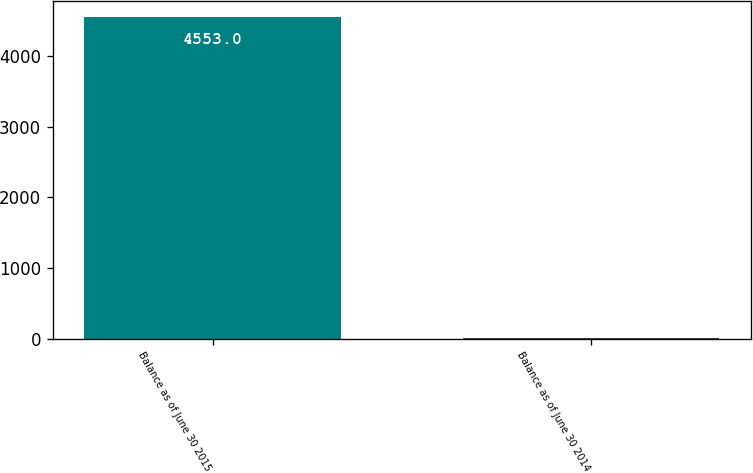Convert chart to OTSL. <chart><loc_0><loc_0><loc_500><loc_500><bar_chart><fcel>Balance as of June 30 2015<fcel>Balance as of June 30 2014<nl><fcel>4553<fcel>12<nl></chart> 